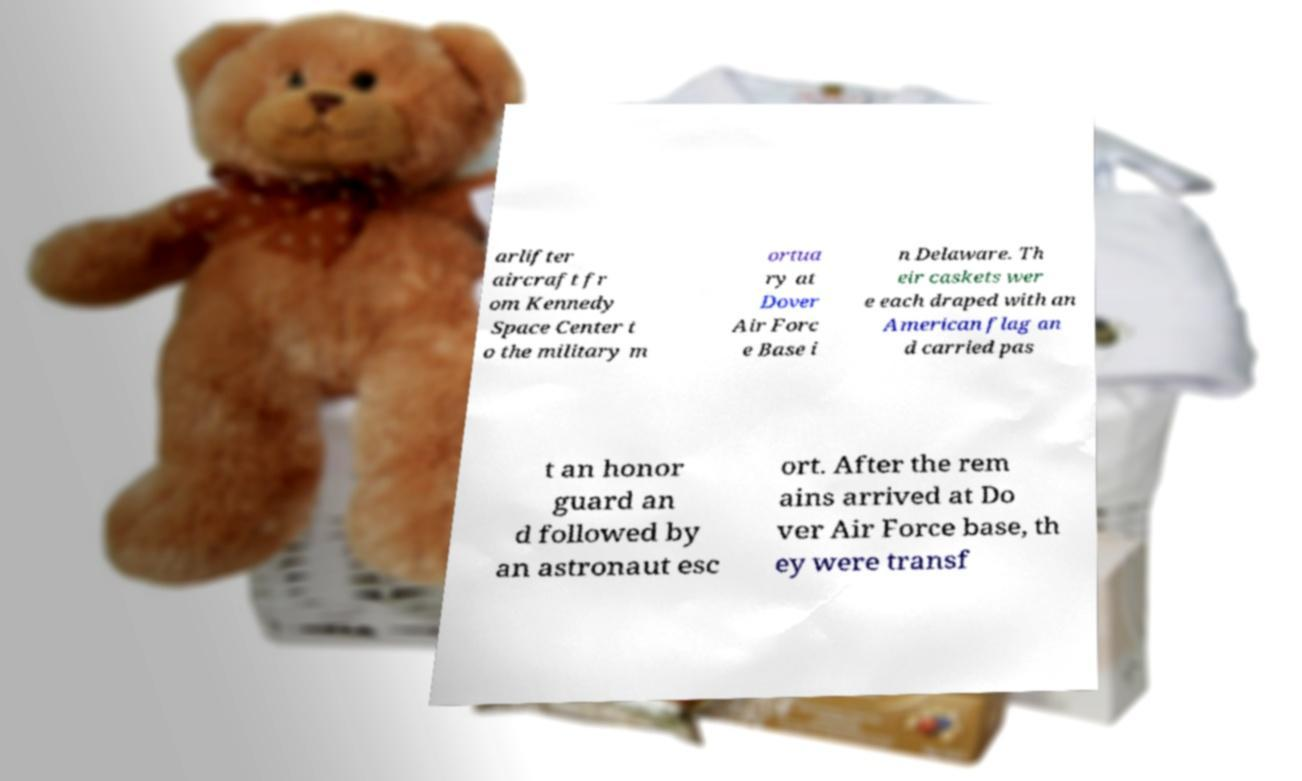Can you read and provide the text displayed in the image?This photo seems to have some interesting text. Can you extract and type it out for me? arlifter aircraft fr om Kennedy Space Center t o the military m ortua ry at Dover Air Forc e Base i n Delaware. Th eir caskets wer e each draped with an American flag an d carried pas t an honor guard an d followed by an astronaut esc ort. After the rem ains arrived at Do ver Air Force base, th ey were transf 